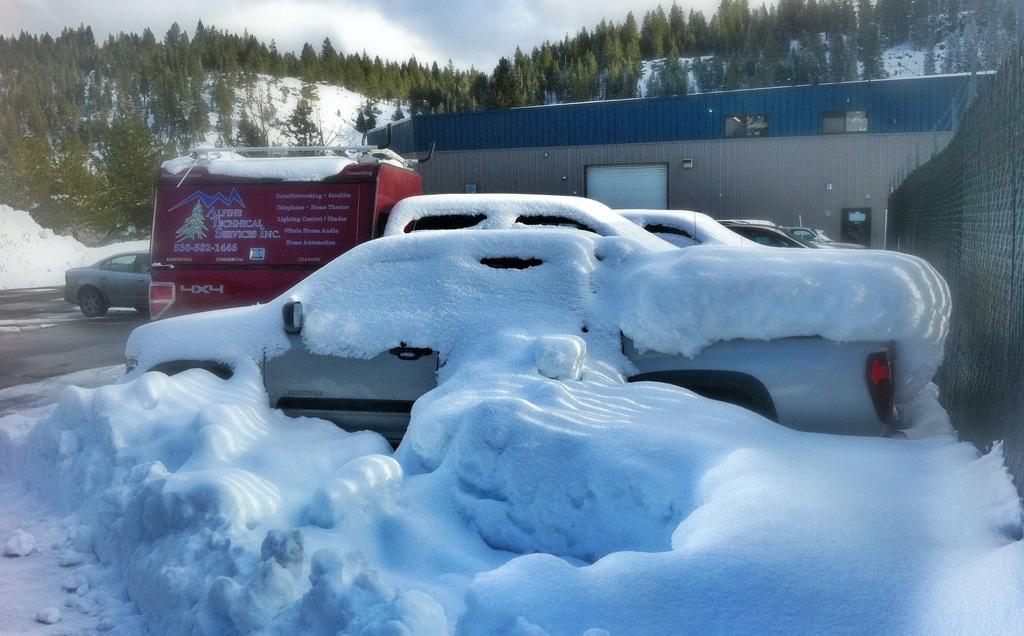Describe this image in one or two sentences. In this image we can see the shed, wall with the railing and also the trees. We can also see the vehicles and some vehicles are covered with the snow. We can see the road and also the sky with the clouds. 